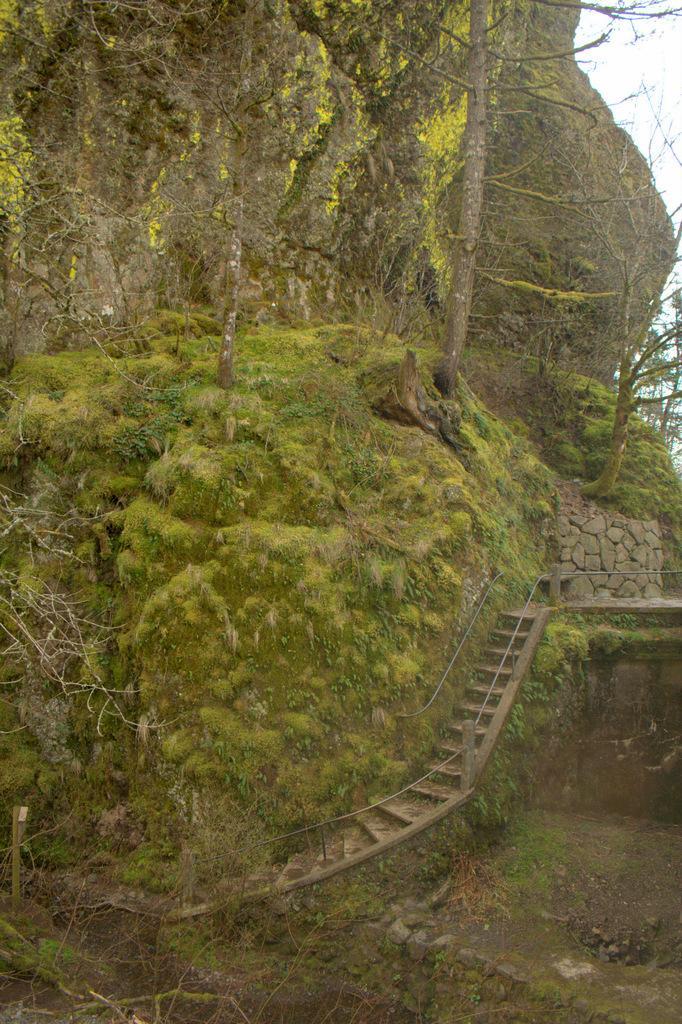Please provide a concise description of this image. It is a hill, there are green trees on this, In the middle it's a staircase. 